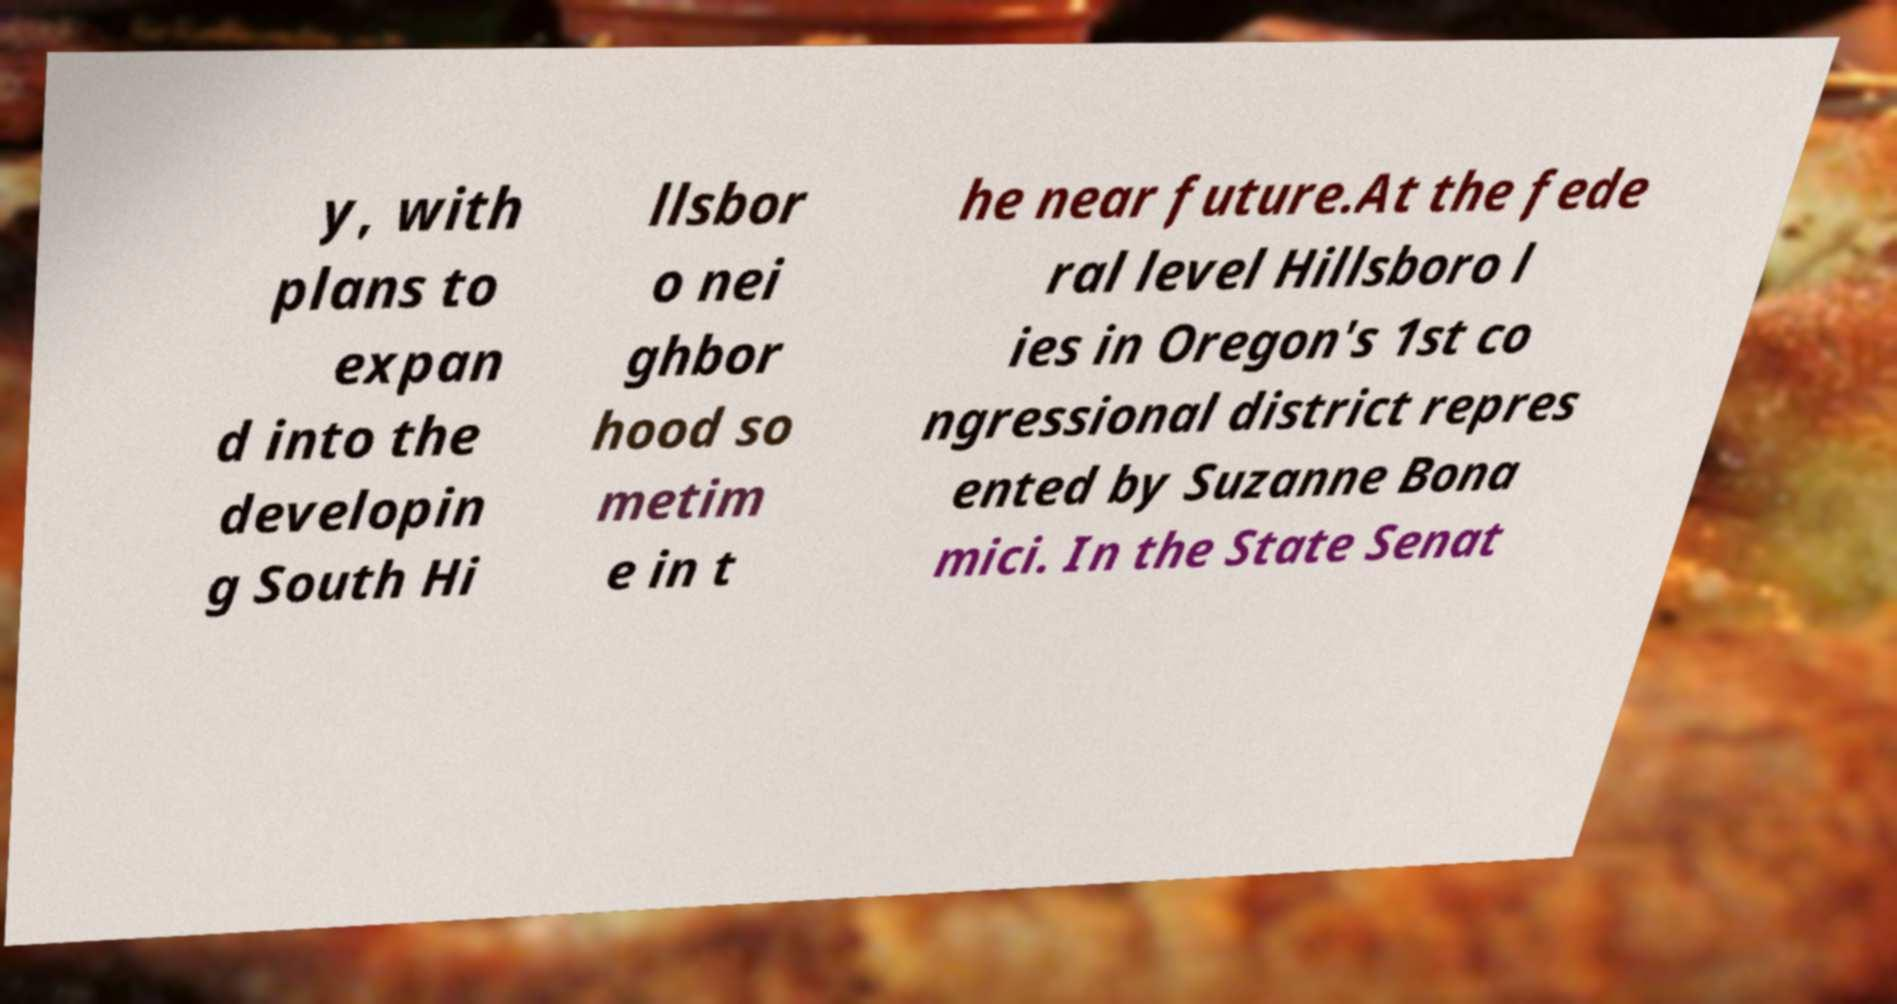For documentation purposes, I need the text within this image transcribed. Could you provide that? y, with plans to expan d into the developin g South Hi llsbor o nei ghbor hood so metim e in t he near future.At the fede ral level Hillsboro l ies in Oregon's 1st co ngressional district repres ented by Suzanne Bona mici. In the State Senat 